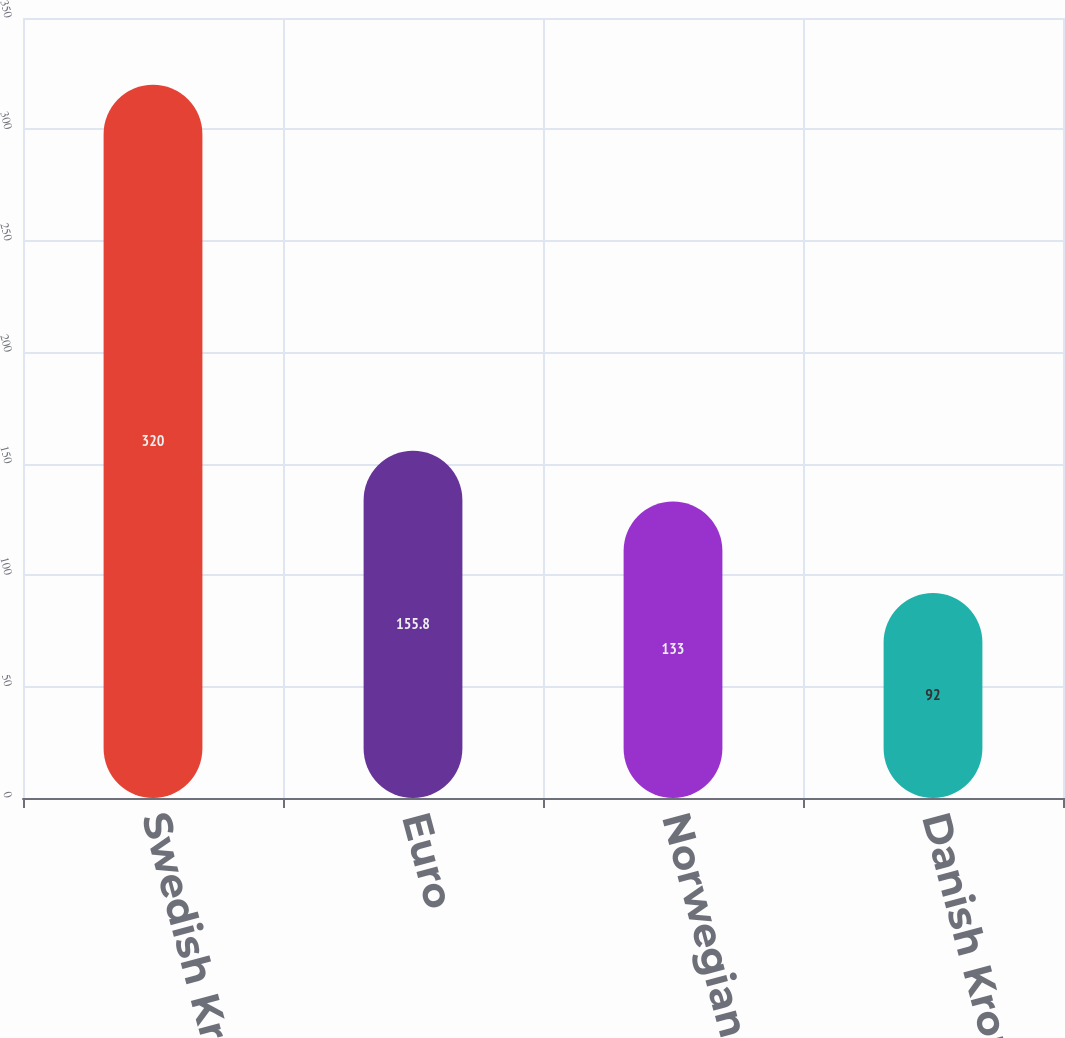Convert chart to OTSL. <chart><loc_0><loc_0><loc_500><loc_500><bar_chart><fcel>Swedish Krona<fcel>Euro<fcel>Norwegian Krone<fcel>Danish Krone<nl><fcel>320<fcel>155.8<fcel>133<fcel>92<nl></chart> 